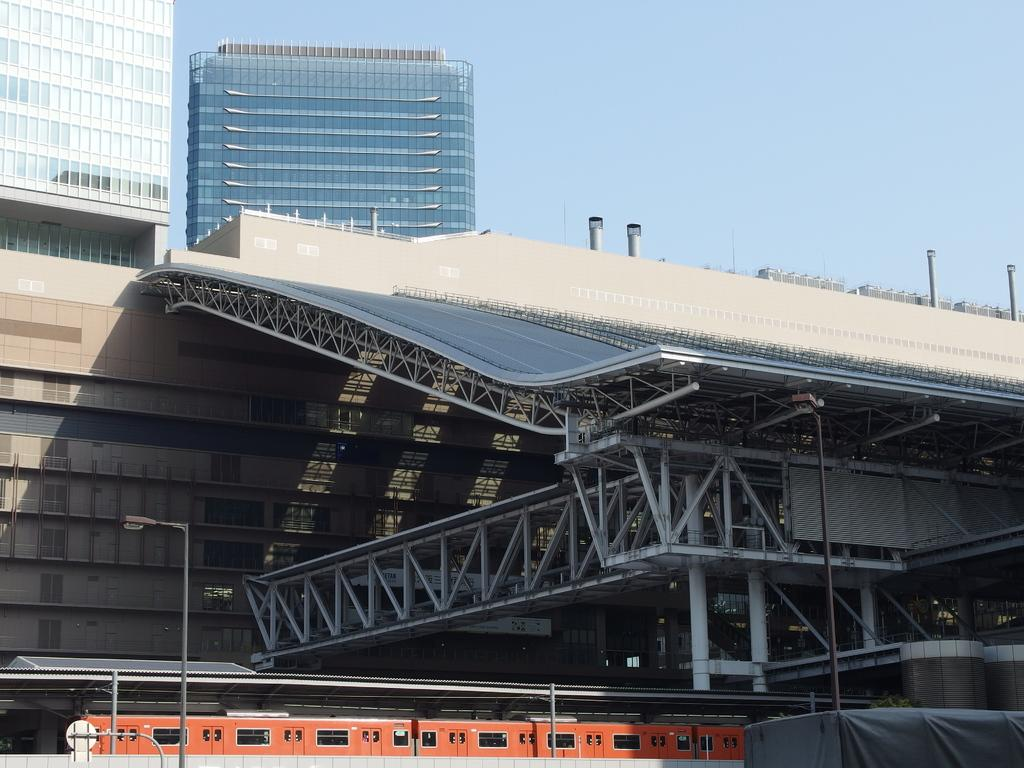What type of structures can be seen in the image? There are buildings and a metal shed in the image. What other man-made features are present in the image? There is a bridge and a street light in the image. What mode of transportation is visible in the image? There is a train in the image. What can be seen in the background of the image? The sky is visible in the background of the image. What type of powder is being used to clean the cows in the image? There are no cows or powder present in the image. 